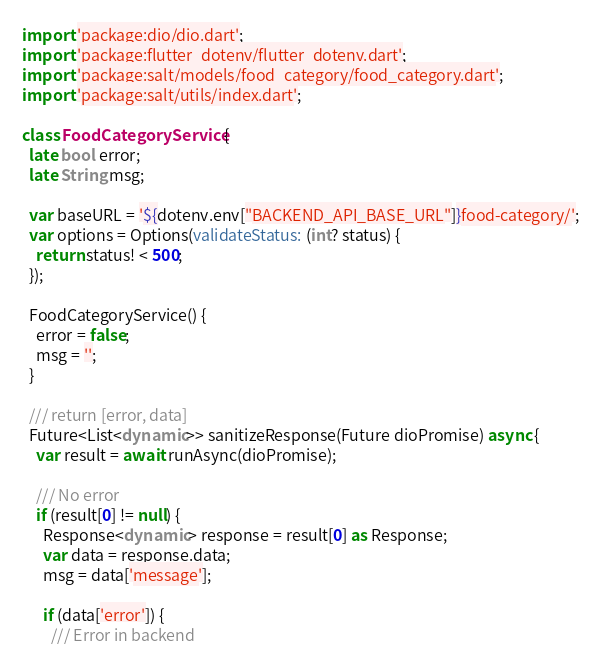<code> <loc_0><loc_0><loc_500><loc_500><_Dart_>import 'package:dio/dio.dart';
import 'package:flutter_dotenv/flutter_dotenv.dart';
import 'package:salt/models/food_category/food_category.dart';
import 'package:salt/utils/index.dart';

class FoodCategoryService {
  late bool error;
  late String msg;

  var baseURL = '${dotenv.env["BACKEND_API_BASE_URL"]}food-category/';
  var options = Options(validateStatus: (int? status) {
    return status! < 500;
  });

  FoodCategoryService() {
    error = false;
    msg = '';
  }

  /// return [error, data]
  Future<List<dynamic>> sanitizeResponse(Future dioPromise) async {
    var result = await runAsync(dioPromise);

    /// No error
    if (result[0] != null) {
      Response<dynamic> response = result[0] as Response;
      var data = response.data;
      msg = data['message'];

      if (data['error']) {
        /// Error in backend</code> 